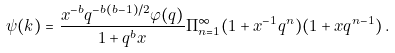Convert formula to latex. <formula><loc_0><loc_0><loc_500><loc_500>\psi ( k ) = \frac { x ^ { - b } q ^ { - b ( b - 1 ) / 2 } \varphi ( q ) } { 1 + q ^ { b } x } \Pi ^ { \infty } _ { n = 1 } ( 1 + x ^ { - 1 } q ^ { n } ) ( 1 + x q ^ { n - 1 } ) \, .</formula> 